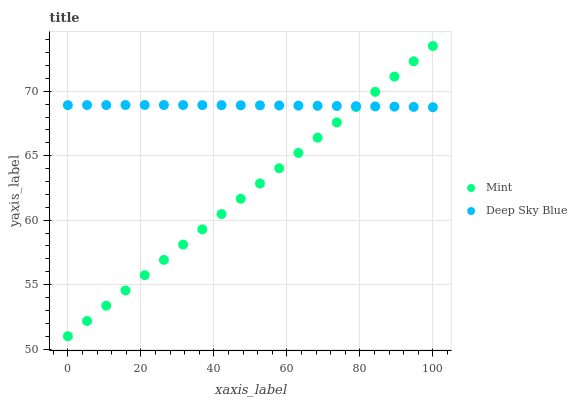Does Mint have the minimum area under the curve?
Answer yes or no. Yes. Does Deep Sky Blue have the maximum area under the curve?
Answer yes or no. Yes. Does Deep Sky Blue have the minimum area under the curve?
Answer yes or no. No. Is Mint the smoothest?
Answer yes or no. Yes. Is Deep Sky Blue the roughest?
Answer yes or no. Yes. Is Deep Sky Blue the smoothest?
Answer yes or no. No. Does Mint have the lowest value?
Answer yes or no. Yes. Does Deep Sky Blue have the lowest value?
Answer yes or no. No. Does Mint have the highest value?
Answer yes or no. Yes. Does Deep Sky Blue have the highest value?
Answer yes or no. No. Does Mint intersect Deep Sky Blue?
Answer yes or no. Yes. Is Mint less than Deep Sky Blue?
Answer yes or no. No. Is Mint greater than Deep Sky Blue?
Answer yes or no. No. 